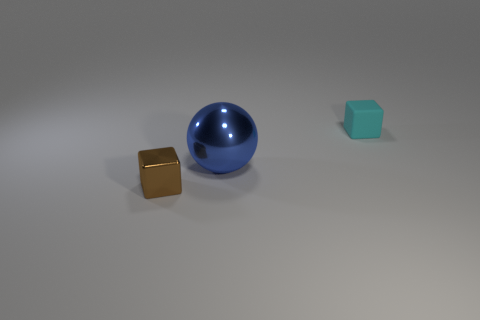What color is the other object that is the same shape as the brown thing?
Give a very brief answer. Cyan. There is a brown object in front of the small thing that is right of the tiny brown shiny block; what number of small blocks are on the right side of it?
Offer a very short reply. 1. There is a small matte thing; is it the same shape as the small object in front of the cyan matte cube?
Your response must be concise. Yes. Are there more large cubes than small brown objects?
Keep it short and to the point. No. Is there any other thing that is the same size as the blue ball?
Your answer should be very brief. No. Do the tiny thing in front of the cyan matte cube and the cyan object have the same shape?
Offer a terse response. Yes. Is the number of small cubes in front of the cyan block greater than the number of metal cylinders?
Keep it short and to the point. Yes. There is a thing behind the blue object to the right of the tiny brown metal block; what is its color?
Provide a short and direct response. Cyan. How many tiny blocks are there?
Offer a terse response. 2. What number of things are on the right side of the brown block and to the left of the small cyan rubber cube?
Your answer should be very brief. 1. 